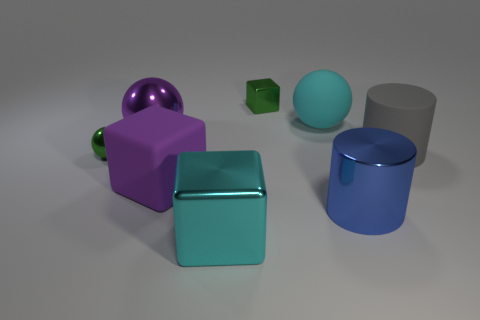There is a small thing that is the same color as the tiny ball; what is its shape?
Ensure brevity in your answer.  Cube. What is the material of the thing that is both left of the cyan rubber object and behind the big purple metal sphere?
Give a very brief answer. Metal. The cyan ball is what size?
Provide a short and direct response. Large. What number of large spheres are right of the tiny green shiny thing that is to the right of the green metal object in front of the large rubber cylinder?
Ensure brevity in your answer.  1. What is the shape of the green metal object on the right side of the big block that is in front of the big purple cube?
Offer a very short reply. Cube. The green metal thing that is the same shape as the large cyan rubber thing is what size?
Provide a short and direct response. Small. Are there any other things that have the same size as the blue shiny object?
Make the answer very short. Yes. What color is the big metal object on the right side of the big cyan metallic block?
Give a very brief answer. Blue. What is the material of the cube behind the green thing in front of the big object that is to the right of the blue object?
Provide a short and direct response. Metal. There is a cyan thing behind the large purple thing behind the rubber cylinder; what is its size?
Give a very brief answer. Large. 